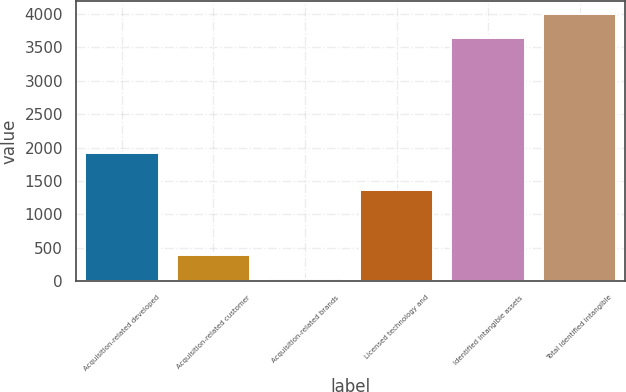Convert chart to OTSL. <chart><loc_0><loc_0><loc_500><loc_500><bar_chart><fcel>Acquisition-related developed<fcel>Acquisition-related customer<fcel>Acquisition-related brands<fcel>Licensed technology and<fcel>Identified intangible assets<fcel>Total identified intangible<nl><fcel>1922<fcel>389.5<fcel>29<fcel>1370<fcel>3634<fcel>3994.5<nl></chart> 